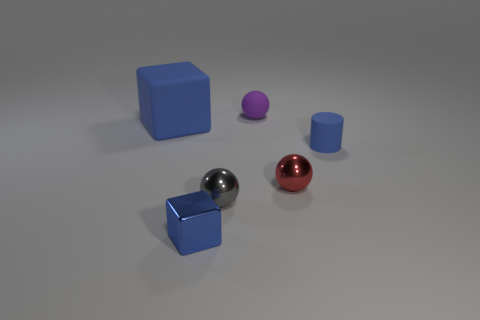Add 1 small blue matte things. How many objects exist? 7 Subtract all cubes. How many objects are left? 4 Subtract all tiny brown matte cylinders. Subtract all tiny blue rubber objects. How many objects are left? 5 Add 4 rubber cylinders. How many rubber cylinders are left? 5 Add 3 tiny yellow rubber balls. How many tiny yellow rubber balls exist? 3 Subtract 0 blue balls. How many objects are left? 6 